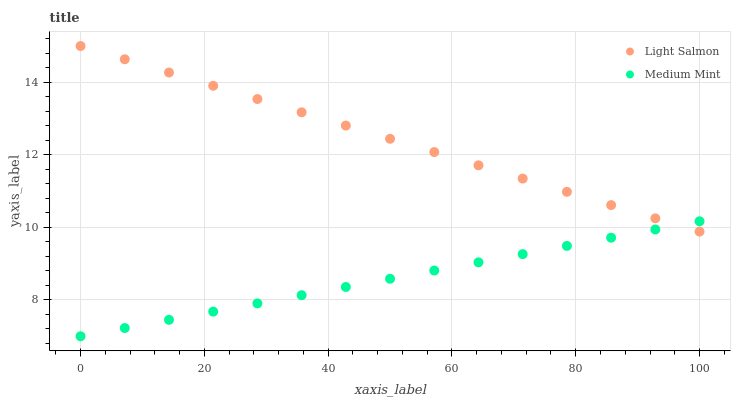Does Medium Mint have the minimum area under the curve?
Answer yes or no. Yes. Does Light Salmon have the maximum area under the curve?
Answer yes or no. Yes. Does Light Salmon have the minimum area under the curve?
Answer yes or no. No. Is Medium Mint the smoothest?
Answer yes or no. Yes. Is Light Salmon the roughest?
Answer yes or no. Yes. Is Light Salmon the smoothest?
Answer yes or no. No. Does Medium Mint have the lowest value?
Answer yes or no. Yes. Does Light Salmon have the lowest value?
Answer yes or no. No. Does Light Salmon have the highest value?
Answer yes or no. Yes. Does Light Salmon intersect Medium Mint?
Answer yes or no. Yes. Is Light Salmon less than Medium Mint?
Answer yes or no. No. Is Light Salmon greater than Medium Mint?
Answer yes or no. No. 